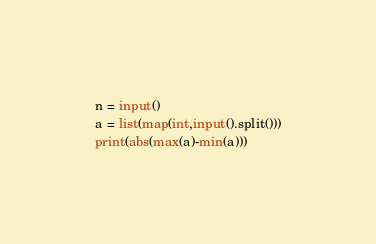<code> <loc_0><loc_0><loc_500><loc_500><_Python_>n = input()
a = list(map(int,input().split()))
print(abs(max(a)-min(a)))</code> 